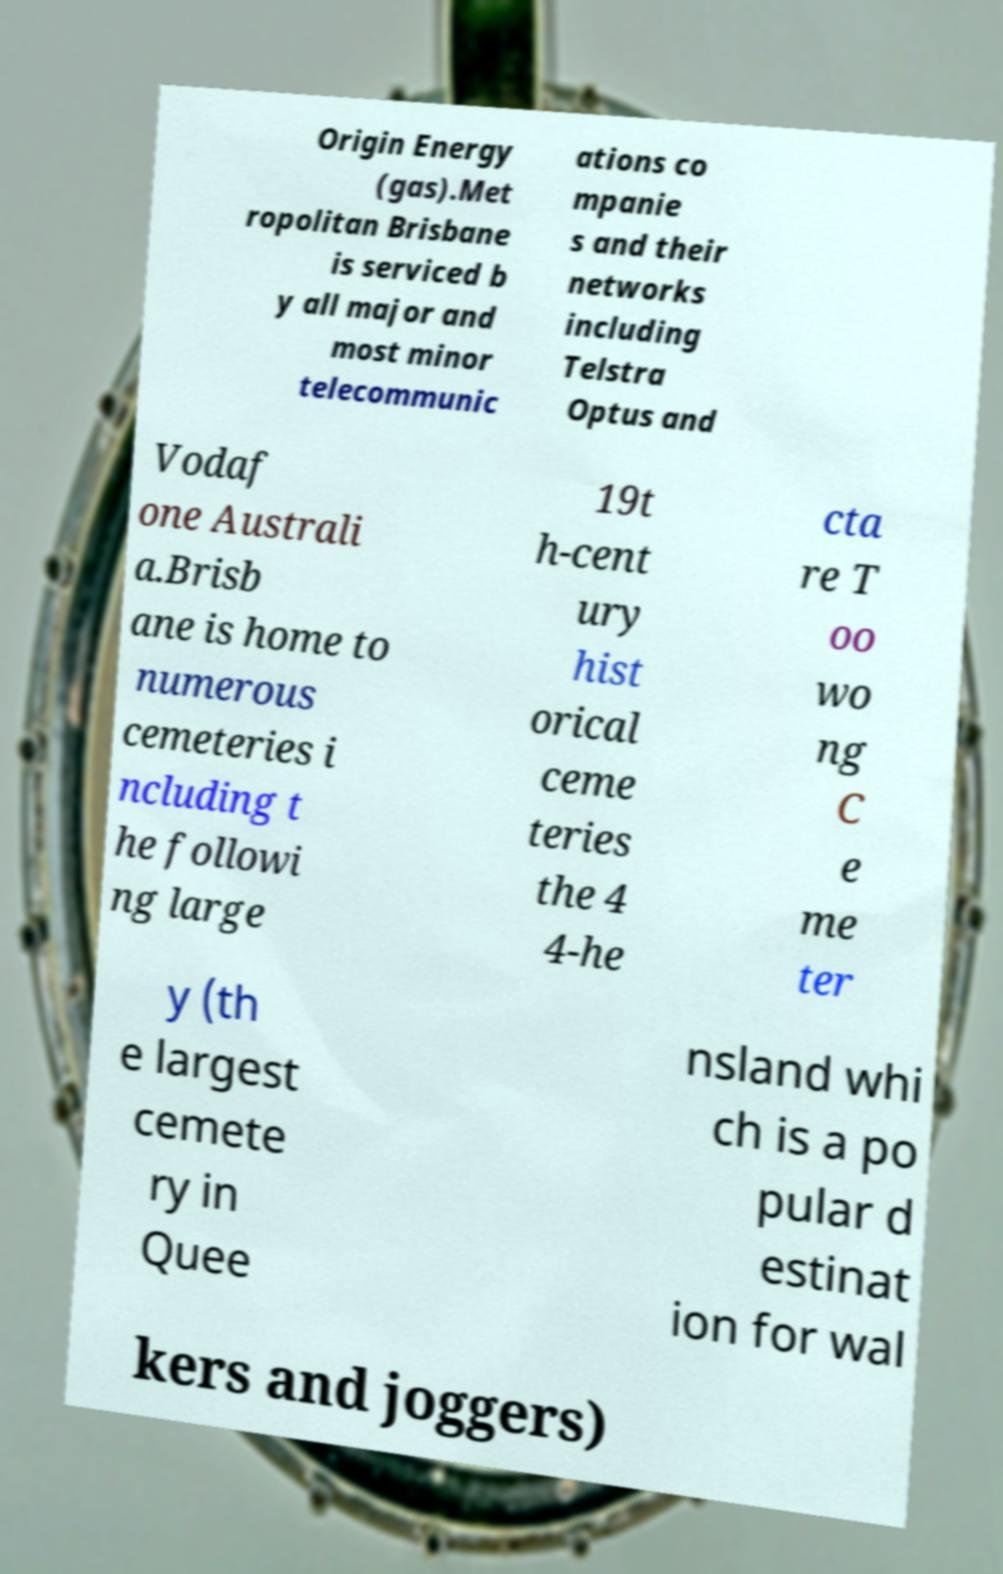I need the written content from this picture converted into text. Can you do that? Origin Energy (gas).Met ropolitan Brisbane is serviced b y all major and most minor telecommunic ations co mpanie s and their networks including Telstra Optus and Vodaf one Australi a.Brisb ane is home to numerous cemeteries i ncluding t he followi ng large 19t h-cent ury hist orical ceme teries the 4 4-he cta re T oo wo ng C e me ter y (th e largest cemete ry in Quee nsland whi ch is a po pular d estinat ion for wal kers and joggers) 